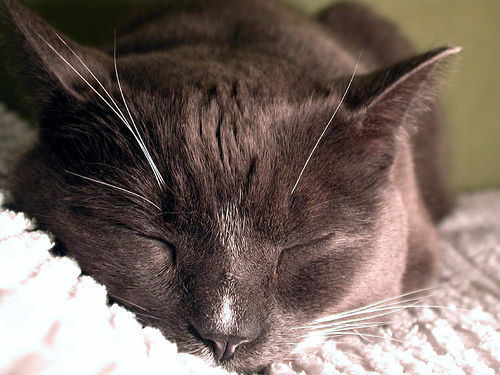<image>
Is the cat in front of the blanket? No. The cat is not in front of the blanket. The spatial positioning shows a different relationship between these objects. 